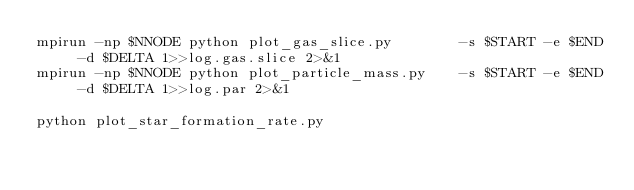<code> <loc_0><loc_0><loc_500><loc_500><_Bash_>mpirun -np $NNODE python plot_gas_slice.py        -s $START -e $END -d $DELTA 1>>log.gas.slice 2>&1
mpirun -np $NNODE python plot_particle_mass.py    -s $START -e $END -d $DELTA 1>>log.par 2>&1

python plot_star_formation_rate.py
</code> 